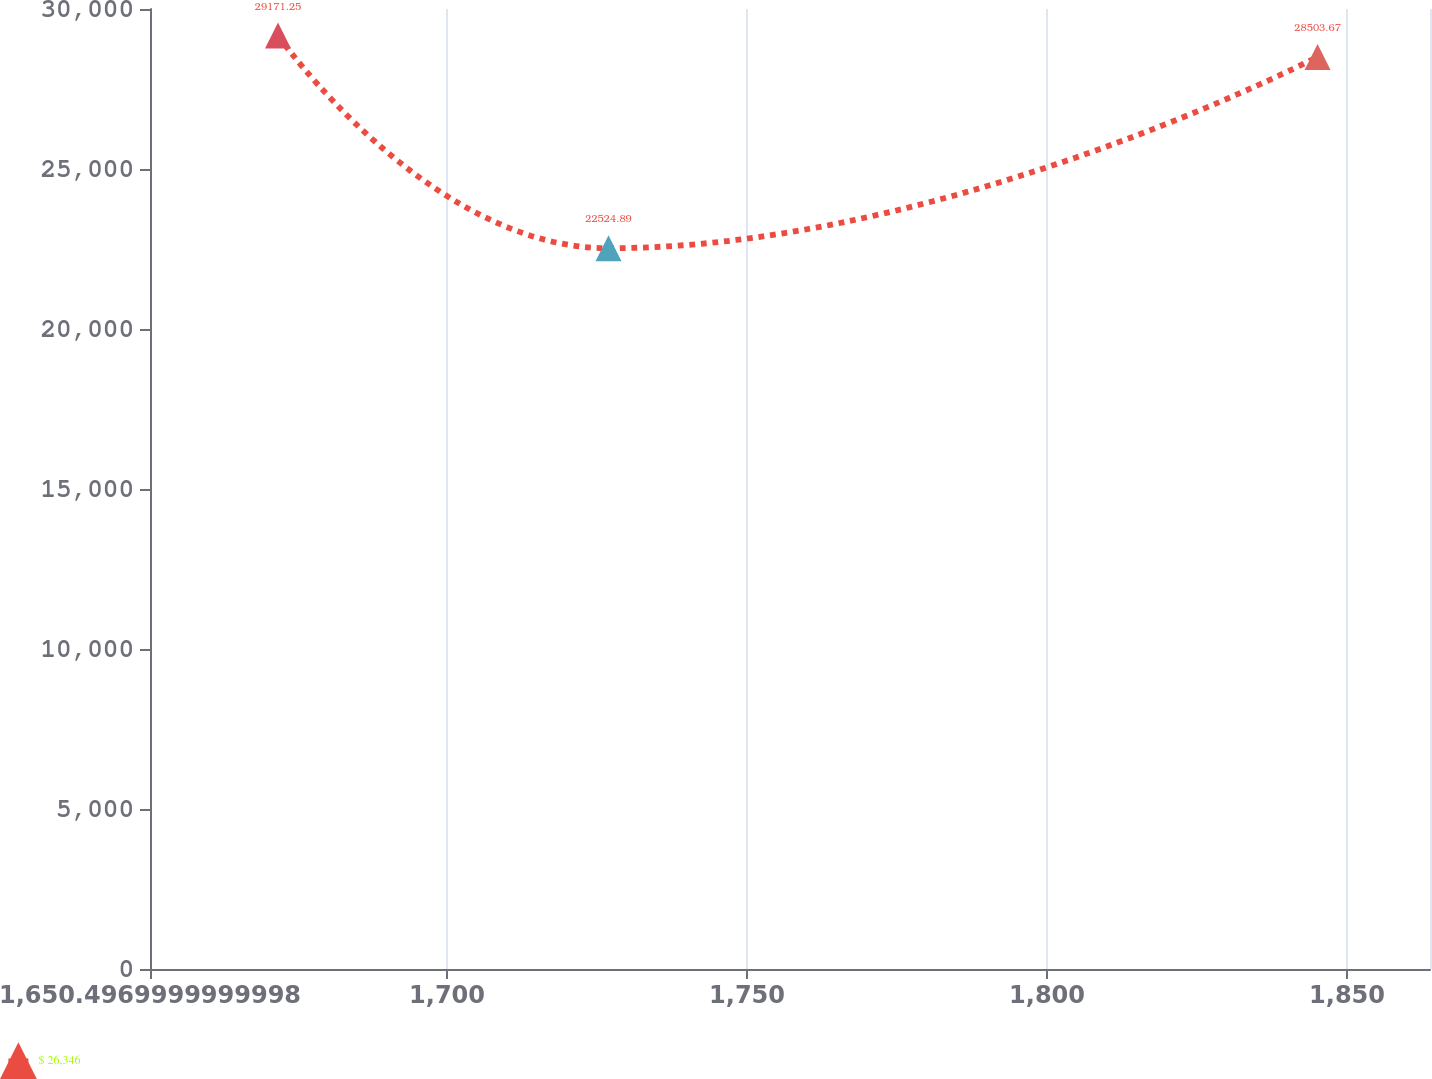Convert chart to OTSL. <chart><loc_0><loc_0><loc_500><loc_500><line_chart><ecel><fcel>$ 26,346<nl><fcel>1671.83<fcel>29171.2<nl><fcel>1726.91<fcel>22524.9<nl><fcel>1845.09<fcel>28503.7<nl><fcel>1885.16<fcel>23968<nl></chart> 